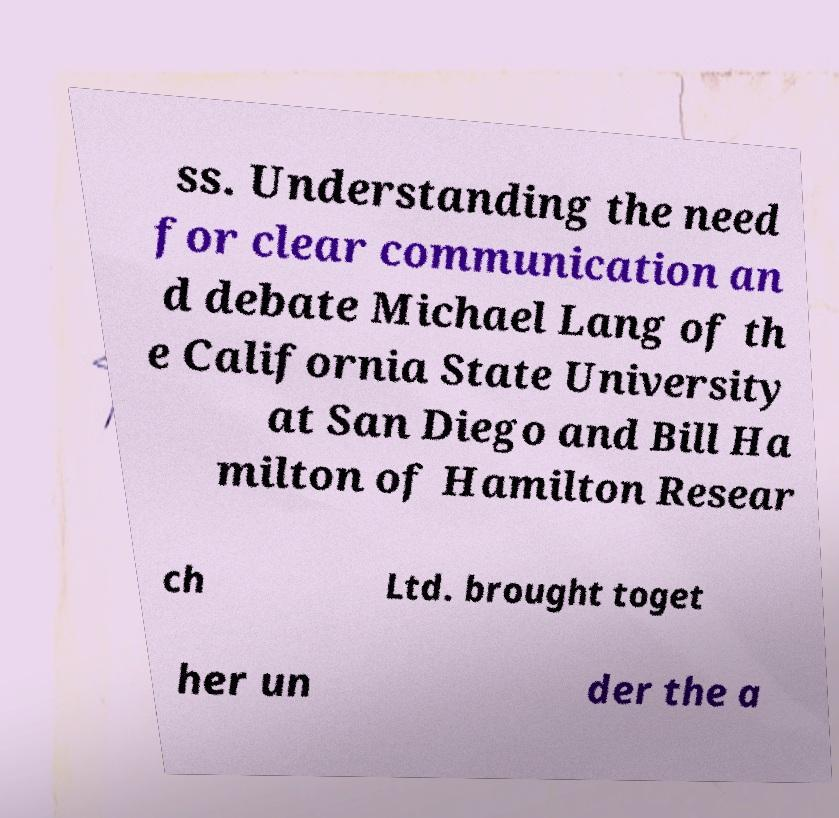Could you assist in decoding the text presented in this image and type it out clearly? ss. Understanding the need for clear communication an d debate Michael Lang of th e California State University at San Diego and Bill Ha milton of Hamilton Resear ch Ltd. brought toget her un der the a 